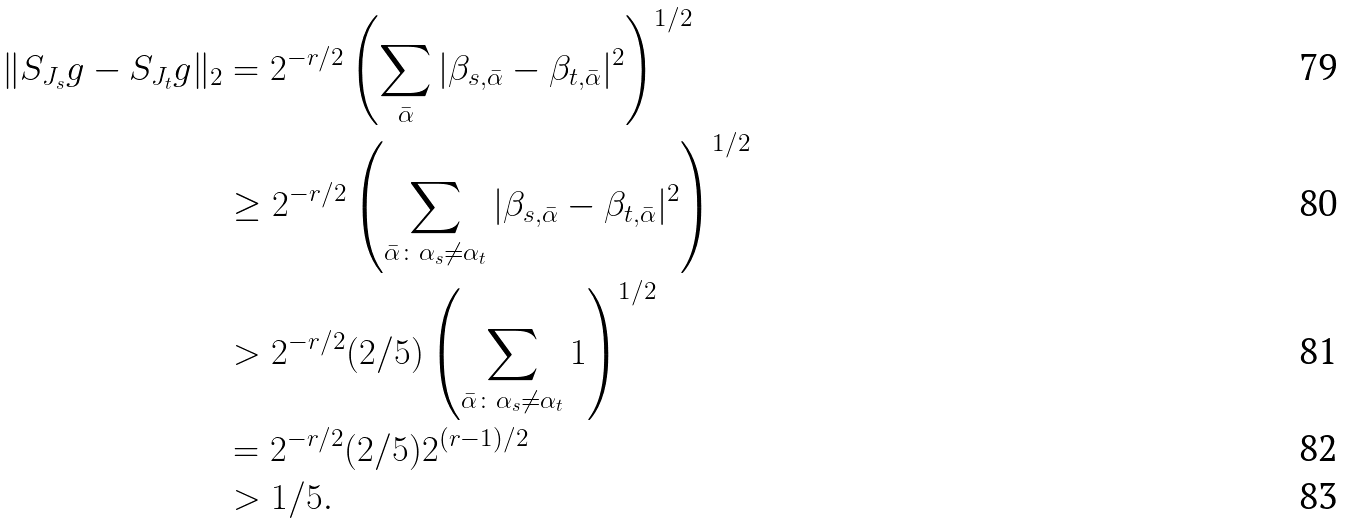Convert formula to latex. <formula><loc_0><loc_0><loc_500><loc_500>\| S _ { J _ { s } } g - S _ { J _ { t } } g \| _ { 2 } & = 2 ^ { - r / 2 } \left ( \sum _ { \bar { \alpha } } | \beta _ { s , \bar { \alpha } } - \beta _ { t , \bar { \alpha } } | ^ { 2 } \right ) ^ { 1 / 2 } \\ & \geq 2 ^ { - r / 2 } \left ( \sum _ { \bar { \alpha } \colon \alpha _ { s } \not = \alpha _ { t } } | \beta _ { s , \bar { \alpha } } - \beta _ { t , \bar { \alpha } } | ^ { 2 } \right ) ^ { 1 / 2 } \\ & > 2 ^ { - r / 2 } ( 2 / 5 ) \left ( \sum _ { \bar { \alpha } \colon \alpha _ { s } \not = \alpha _ { t } } 1 \right ) ^ { 1 / 2 } \\ & = 2 ^ { - r / 2 } ( 2 / 5 ) 2 ^ { ( r - 1 ) / 2 } \\ & > 1 / 5 .</formula> 